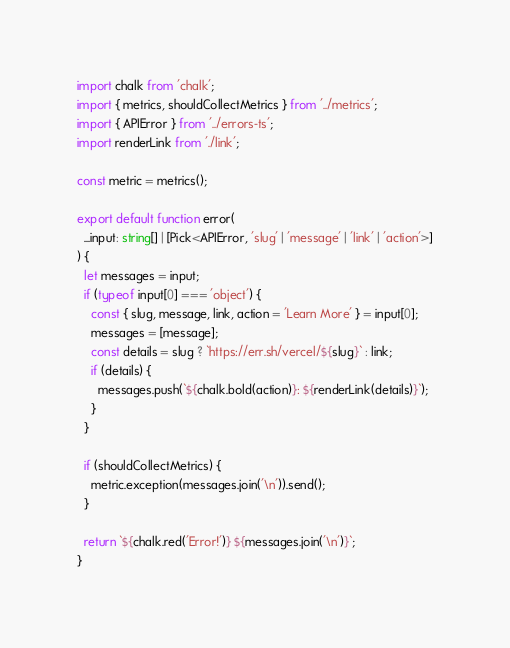<code> <loc_0><loc_0><loc_500><loc_500><_TypeScript_>import chalk from 'chalk';
import { metrics, shouldCollectMetrics } from '../metrics';
import { APIError } from '../errors-ts';
import renderLink from './link';

const metric = metrics();

export default function error(
  ...input: string[] | [Pick<APIError, 'slug' | 'message' | 'link' | 'action'>]
) {
  let messages = input;
  if (typeof input[0] === 'object') {
    const { slug, message, link, action = 'Learn More' } = input[0];
    messages = [message];
    const details = slug ? `https://err.sh/vercel/${slug}` : link;
    if (details) {
      messages.push(`${chalk.bold(action)}: ${renderLink(details)}`);
    }
  }

  if (shouldCollectMetrics) {
    metric.exception(messages.join('\n')).send();
  }

  return `${chalk.red('Error!')} ${messages.join('\n')}`;
}
</code> 